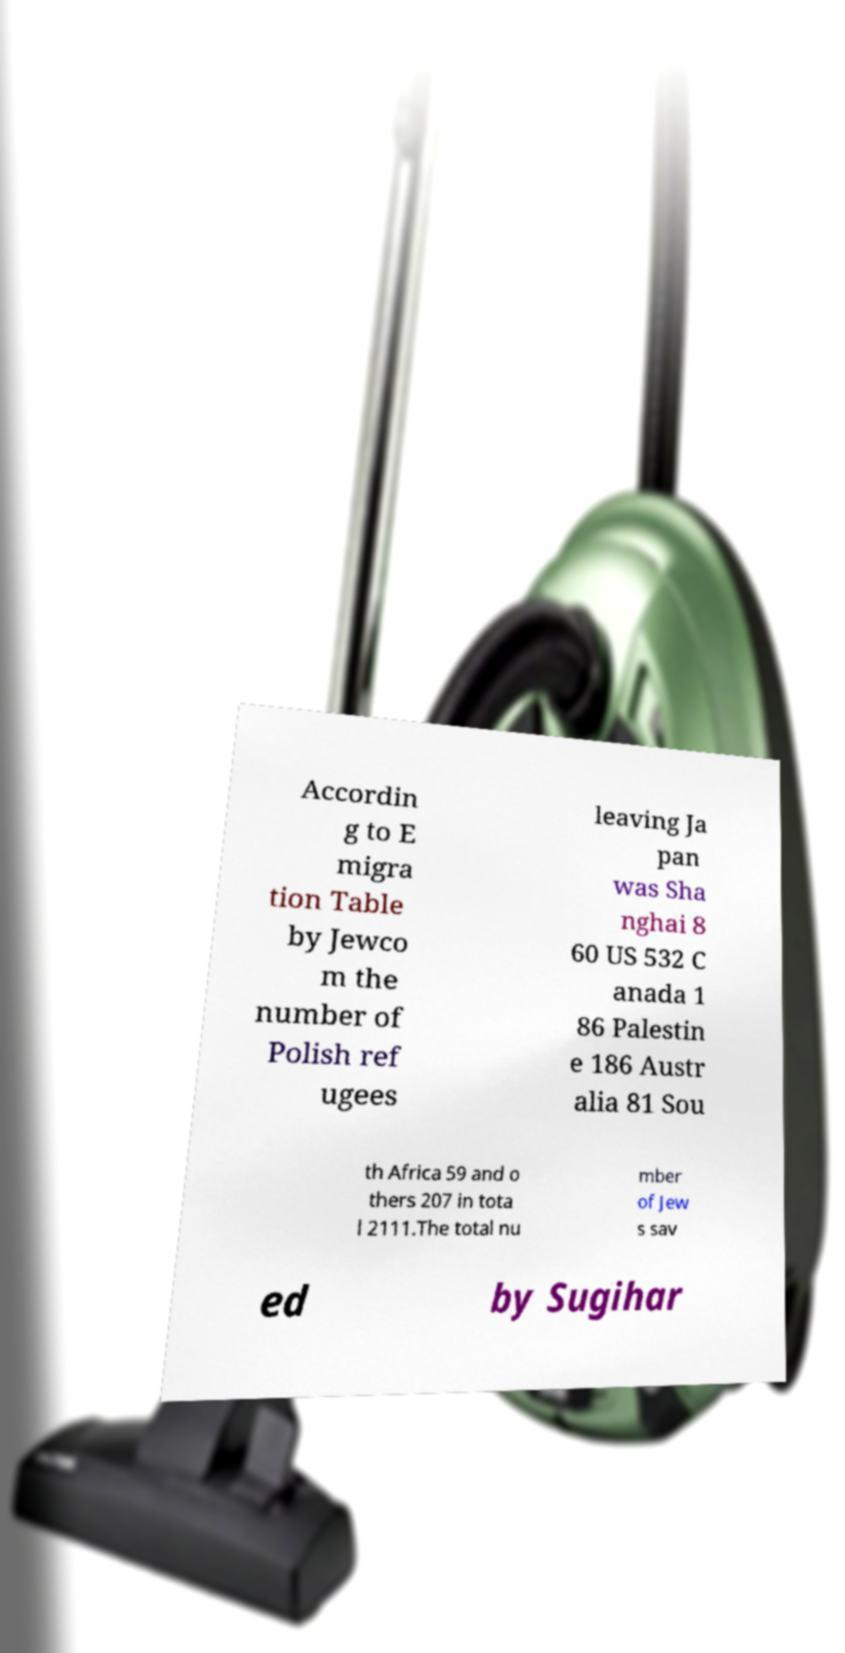What messages or text are displayed in this image? I need them in a readable, typed format. Accordin g to E migra tion Table by Jewco m the number of Polish ref ugees leaving Ja pan was Sha nghai 8 60 US 532 C anada 1 86 Palestin e 186 Austr alia 81 Sou th Africa 59 and o thers 207 in tota l 2111.The total nu mber of Jew s sav ed by Sugihar 